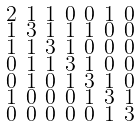<formula> <loc_0><loc_0><loc_500><loc_500>\begin{smallmatrix} 2 & 1 & 1 & 0 & 0 & 1 & 0 \\ 1 & 3 & 1 & 1 & 1 & 0 & 0 \\ 1 & 1 & 3 & 1 & 0 & 0 & 0 \\ 0 & 1 & 1 & 3 & 1 & 0 & 0 \\ 0 & 1 & 0 & 1 & 3 & 1 & 0 \\ 1 & 0 & 0 & 0 & 1 & 3 & 1 \\ 0 & 0 & 0 & 0 & 0 & 1 & 3 \end{smallmatrix}</formula> 